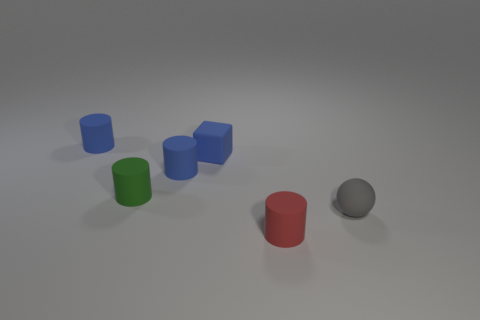Add 4 brown objects. How many objects exist? 10 Subtract all purple cubes. How many blue cylinders are left? 2 Subtract all blue cylinders. How many cylinders are left? 2 Subtract all cylinders. How many objects are left? 2 Subtract all brown balls. Subtract all purple cylinders. How many balls are left? 1 Subtract all small matte things. Subtract all tiny yellow metallic cylinders. How many objects are left? 0 Add 2 red things. How many red things are left? 3 Add 4 small red things. How many small red things exist? 5 Subtract 0 yellow cubes. How many objects are left? 6 